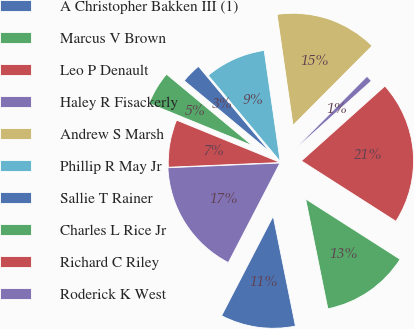<chart> <loc_0><loc_0><loc_500><loc_500><pie_chart><fcel>A Christopher Bakken III (1)<fcel>Marcus V Brown<fcel>Leo P Denault<fcel>Haley R Fisackerly<fcel>Andrew S Marsh<fcel>Phillip R May Jr<fcel>Sallie T Rainer<fcel>Charles L Rice Jr<fcel>Richard C Riley<fcel>Roderick K West<nl><fcel>10.79%<fcel>12.77%<fcel>20.68%<fcel>0.91%<fcel>14.74%<fcel>8.81%<fcel>2.88%<fcel>4.86%<fcel>6.84%<fcel>16.72%<nl></chart> 